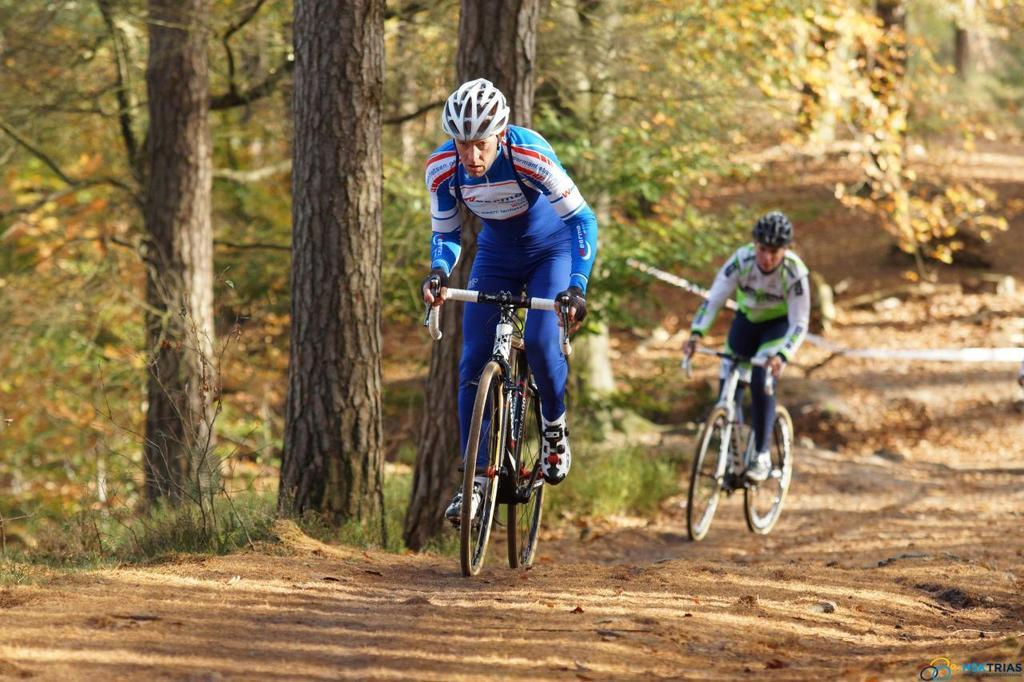How many people are in the image? There are two persons in the image. What are the persons doing in the image? The persons are riding bicycles. Can you describe the clothing of the person in front? The person in front is wearing a blue dress. What can be seen in the background of the image? There are trees in the background of the image. What is the color of the trees? The trees are green in color. What type of glass is being used to roll down the hill in the image? There is no glass or rolling activity present in the image; it features two persons riding bicycles with trees in the background. 